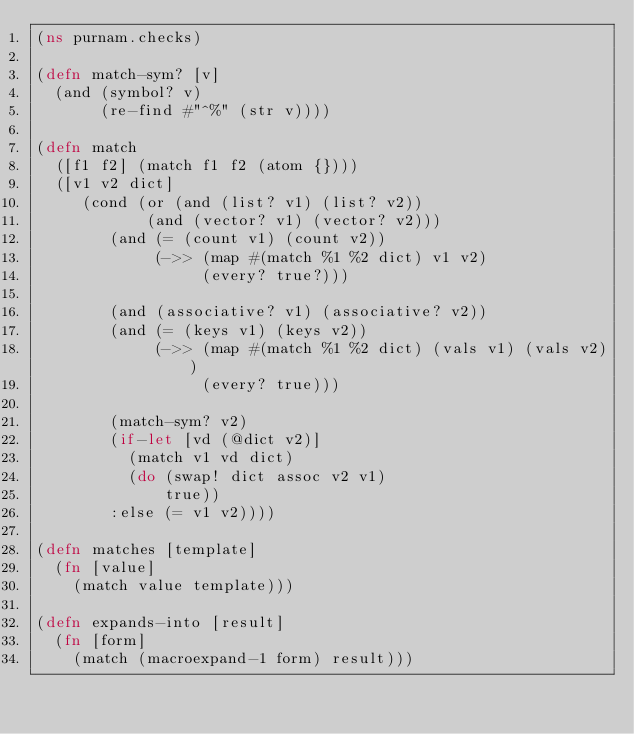<code> <loc_0><loc_0><loc_500><loc_500><_Clojure_>(ns purnam.checks)

(defn match-sym? [v]
  (and (symbol? v)
       (re-find #"^%" (str v))))

(defn match
  ([f1 f2] (match f1 f2 (atom {})))
  ([v1 v2 dict]
     (cond (or (and (list? v1) (list? v2))
            (and (vector? v1) (vector? v2)))
        (and (= (count v1) (count v2))
             (->> (map #(match %1 %2 dict) v1 v2)  
                  (every? true?)))

        (and (associative? v1) (associative? v2))
        (and (= (keys v1) (keys v2))
             (->> (map #(match %1 %2 dict) (vals v1) (vals v2))
                  (every? true)))

        (match-sym? v2)
        (if-let [vd (@dict v2)]
          (match v1 vd dict)
          (do (swap! dict assoc v2 v1)
              true))
        :else (= v1 v2))))
        
(defn matches [template]
  (fn [value]
    (match value template)))

(defn expands-into [result]
  (fn [form]
    (match (macroexpand-1 form) result)))</code> 